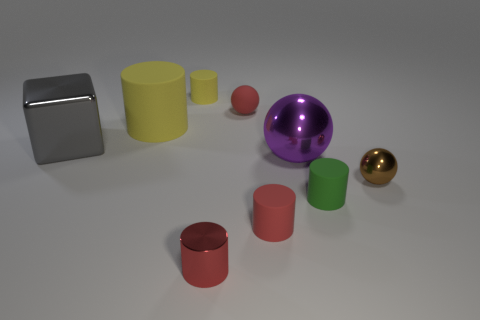There is a tiny matte object that is left of the large metallic ball and in front of the large block; what is its shape?
Ensure brevity in your answer.  Cylinder. What is the size of the shiny object that is the same shape as the tiny green rubber thing?
Make the answer very short. Small. How many tiny purple balls have the same material as the cube?
Provide a succinct answer. 0. Does the large matte thing have the same color as the big shiny block left of the red metal cylinder?
Ensure brevity in your answer.  No. Are there more blue rubber balls than yellow matte objects?
Offer a terse response. No. What is the color of the big shiny cube?
Give a very brief answer. Gray. Is the color of the small cylinder that is on the right side of the tiny red rubber cylinder the same as the large shiny ball?
Provide a succinct answer. No. What material is the small ball that is the same color as the metallic cylinder?
Keep it short and to the point. Rubber. What number of tiny shiny spheres have the same color as the metallic cylinder?
Offer a terse response. 0. Does the red matte thing that is behind the large sphere have the same shape as the small yellow matte object?
Keep it short and to the point. No. 